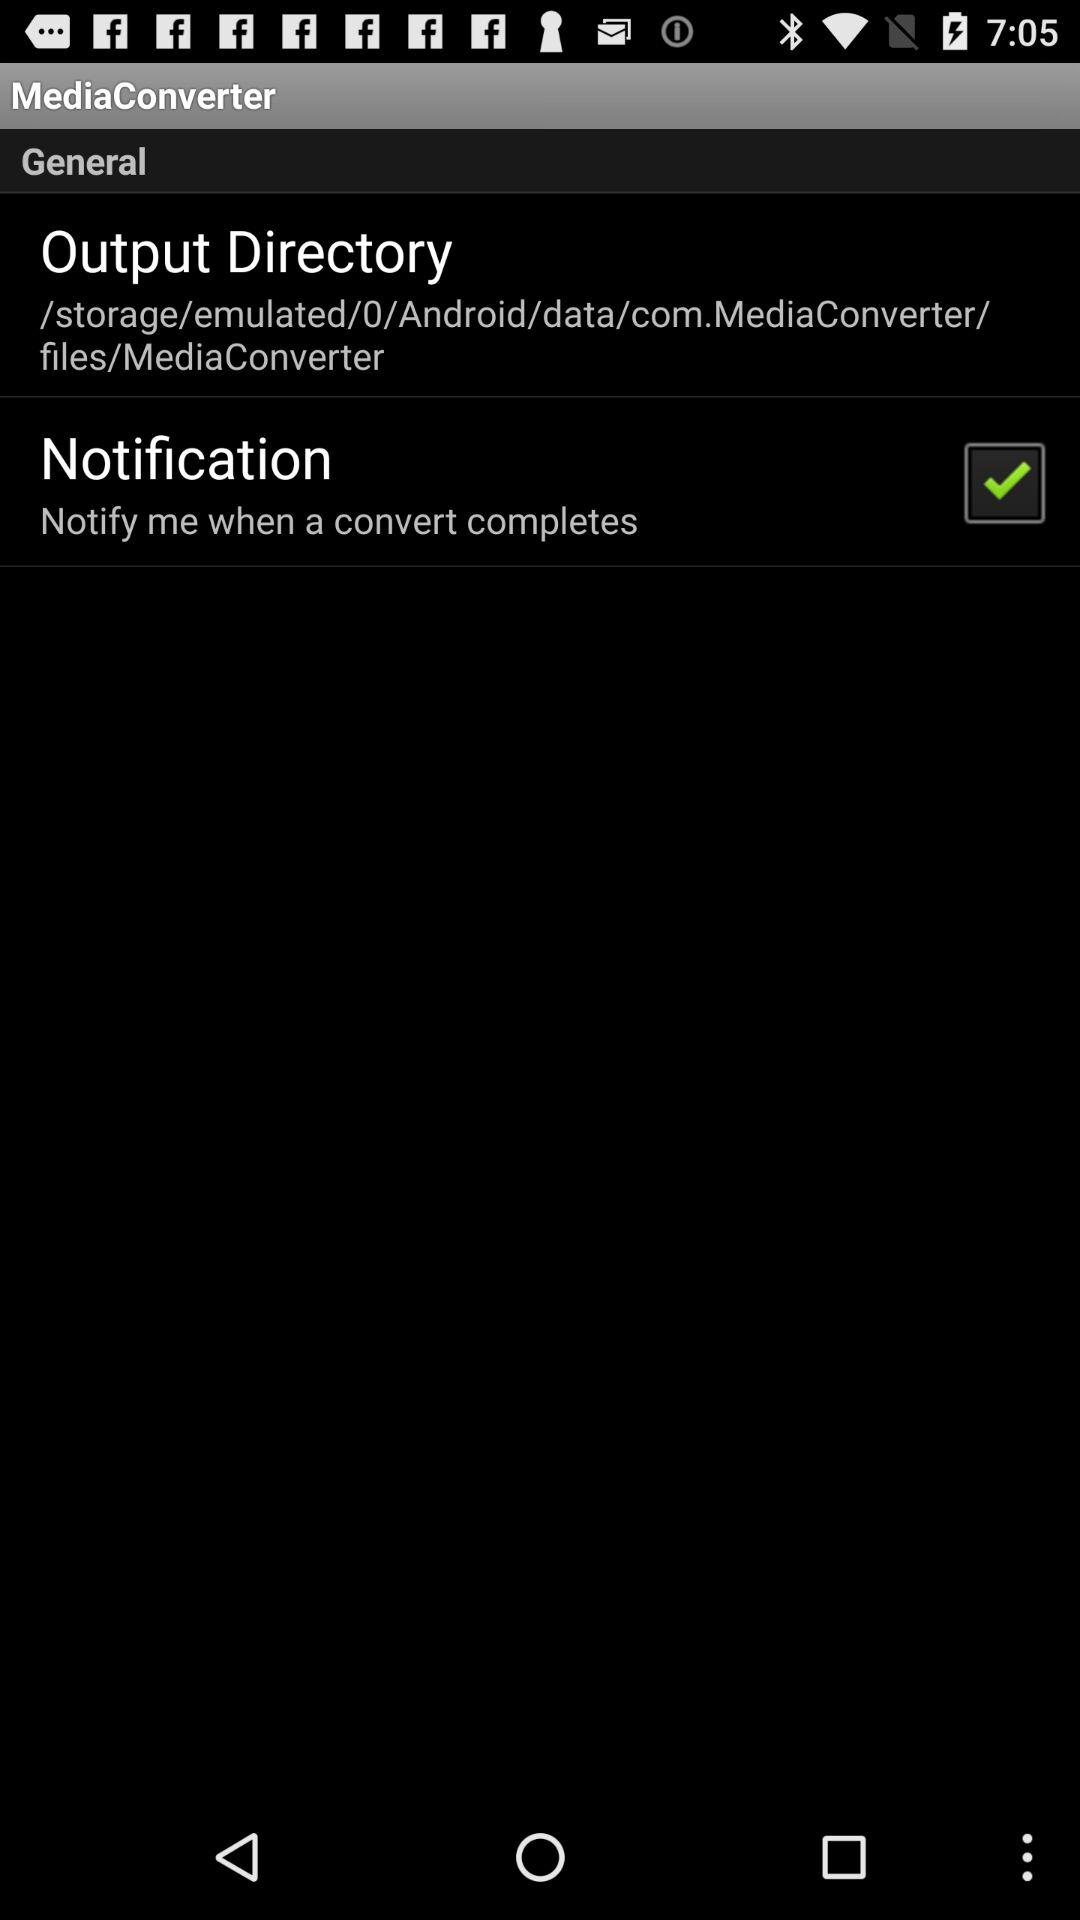What is the file path of the output directory? The file path is "/storage/emulated/0/Android/data/com.MediaConverter/ files/MediaConverter". 